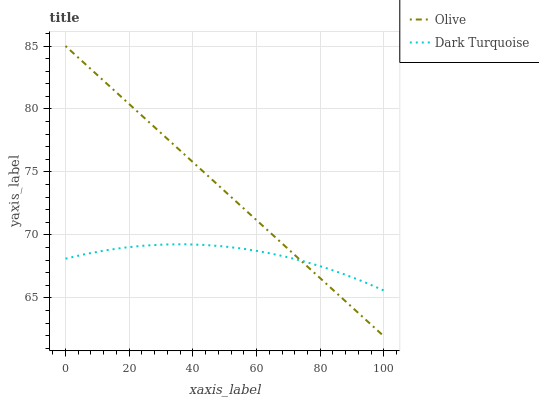Does Dark Turquoise have the minimum area under the curve?
Answer yes or no. Yes. Does Olive have the maximum area under the curve?
Answer yes or no. Yes. Does Dark Turquoise have the maximum area under the curve?
Answer yes or no. No. Is Olive the smoothest?
Answer yes or no. Yes. Is Dark Turquoise the roughest?
Answer yes or no. Yes. Is Dark Turquoise the smoothest?
Answer yes or no. No. Does Olive have the lowest value?
Answer yes or no. Yes. Does Dark Turquoise have the lowest value?
Answer yes or no. No. Does Olive have the highest value?
Answer yes or no. Yes. Does Dark Turquoise have the highest value?
Answer yes or no. No. Does Olive intersect Dark Turquoise?
Answer yes or no. Yes. Is Olive less than Dark Turquoise?
Answer yes or no. No. Is Olive greater than Dark Turquoise?
Answer yes or no. No. 